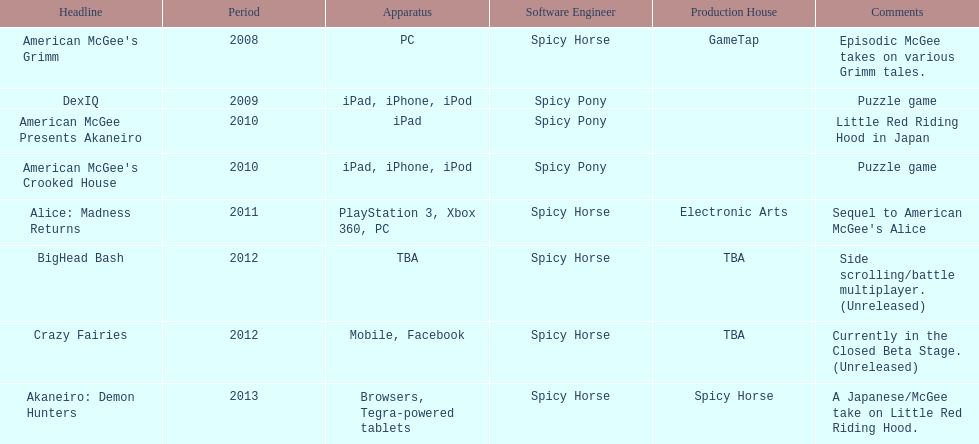According to the table, what is the last title that spicy horse produced? Akaneiro: Demon Hunters. 